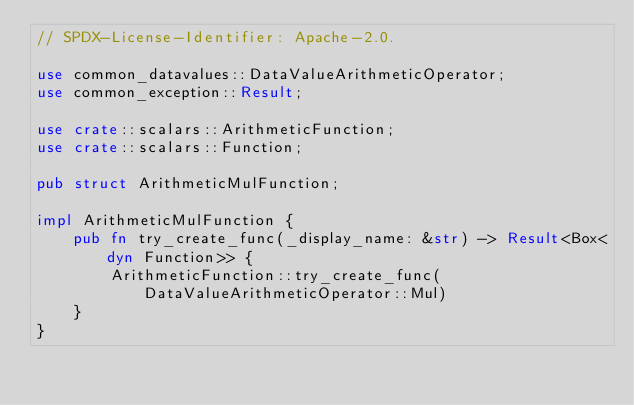<code> <loc_0><loc_0><loc_500><loc_500><_Rust_>// SPDX-License-Identifier: Apache-2.0.

use common_datavalues::DataValueArithmeticOperator;
use common_exception::Result;

use crate::scalars::ArithmeticFunction;
use crate::scalars::Function;

pub struct ArithmeticMulFunction;

impl ArithmeticMulFunction {
    pub fn try_create_func(_display_name: &str) -> Result<Box<dyn Function>> {
        ArithmeticFunction::try_create_func(DataValueArithmeticOperator::Mul)
    }
}
</code> 